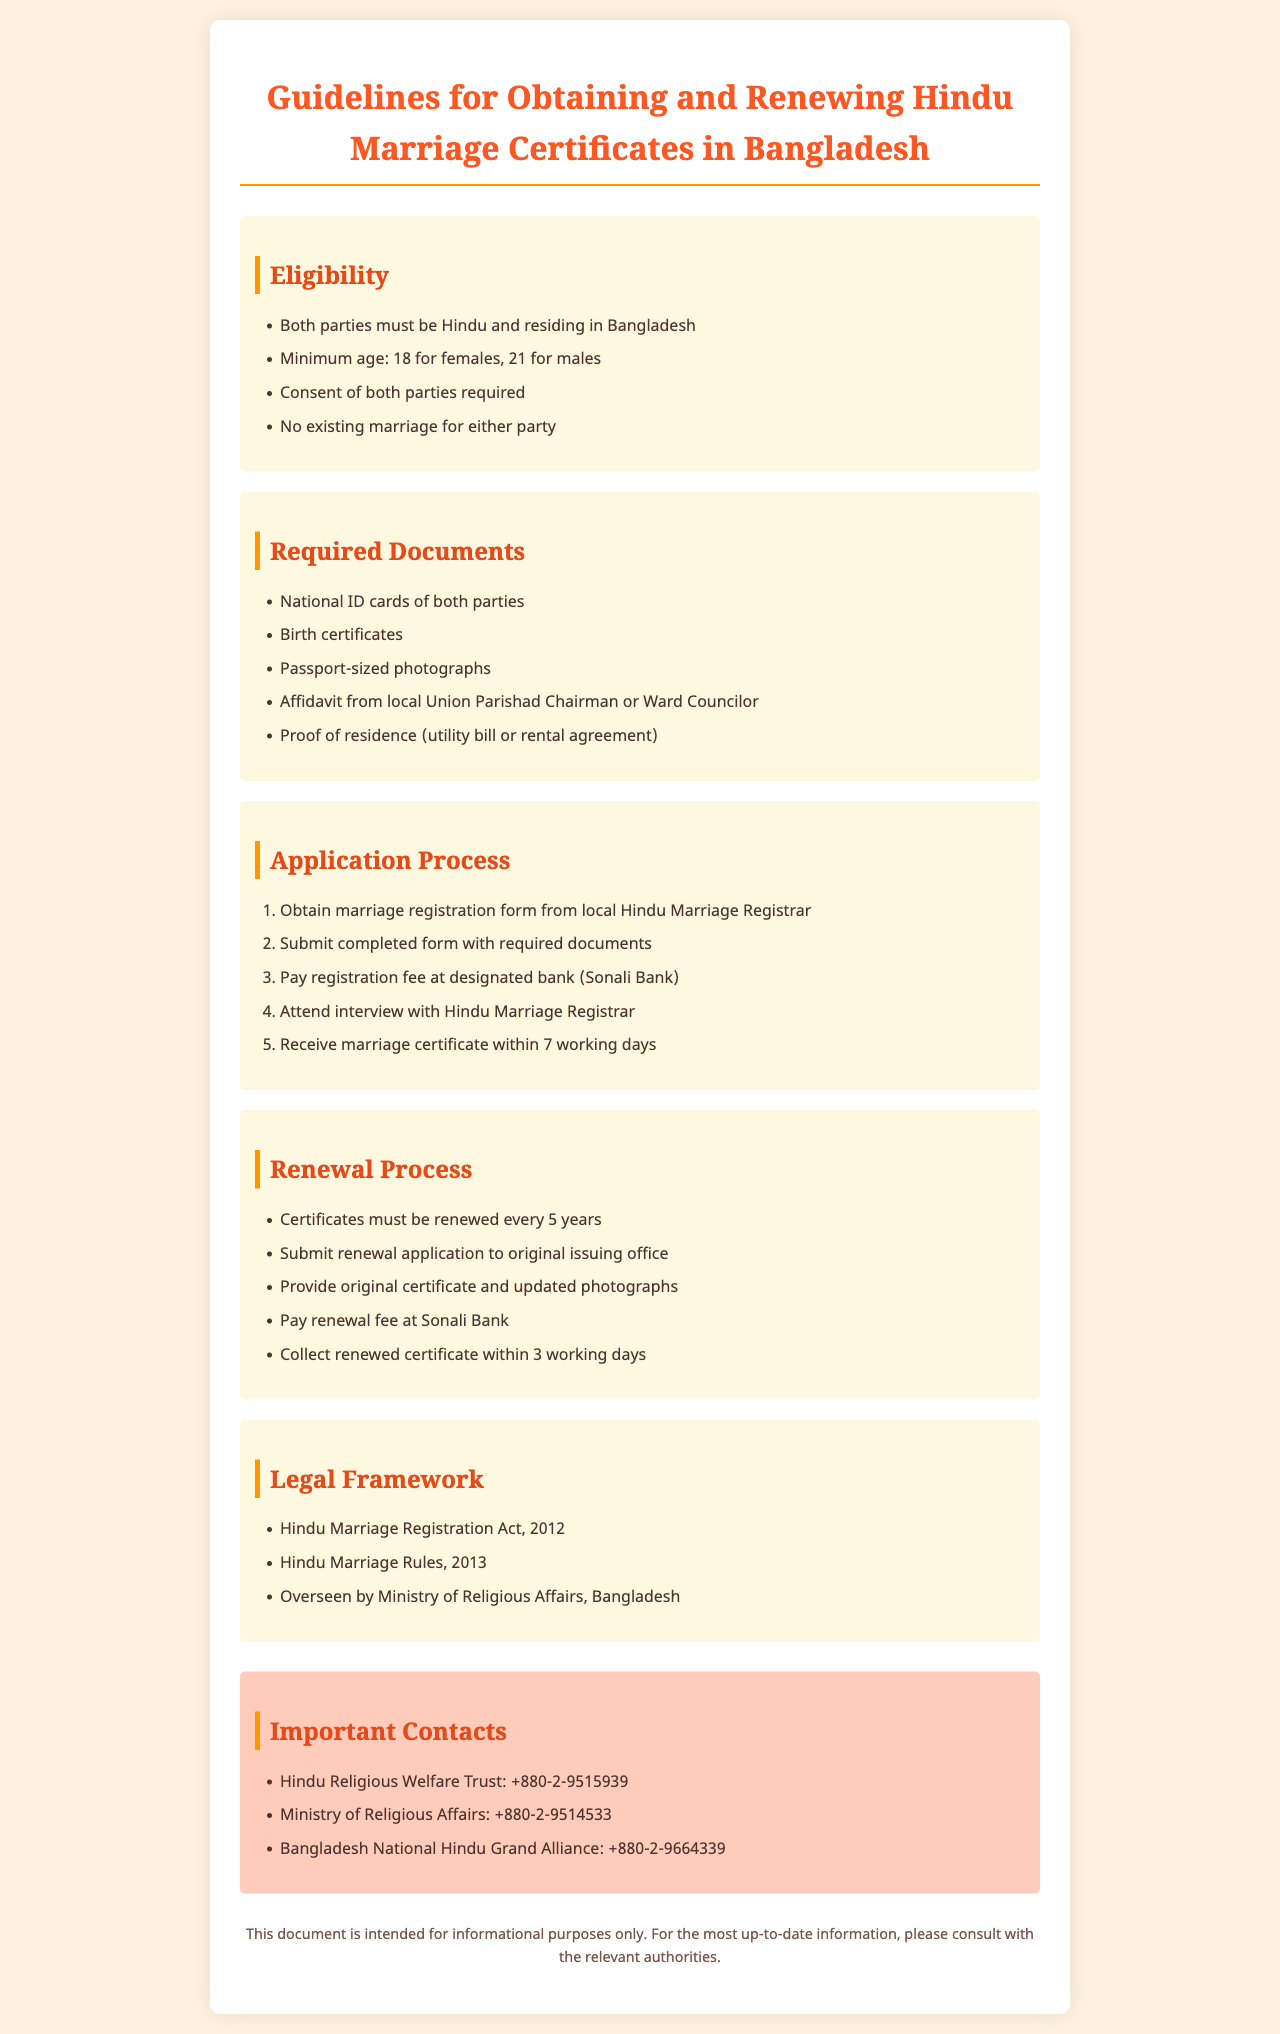What is the minimum age for females to marry? The document states that the minimum age for females is 18.
Answer: 18 What documents are needed for marriage registration? The document provides a list of required documents which includes national ID cards and birth certificates.
Answer: National ID cards, Birth certificates, Passport-sized photographs, Affidavit, Proof of residence How long does it take to receive the marriage certificate? The document mentions that the marriage certificate is received within 7 working days.
Answer: 7 working days What is the renewal period for the marriage certificate? According to the document, certificates must be renewed every 5 years.
Answer: 5 years Who oversees the Hindu Marriage Registration in Bangladesh? The document states that it is overseen by the Ministry of Religious Affairs.
Answer: Ministry of Religious Affairs What is the designated bank for paying the registration fee? The guideline mentions paying the fee at Sonali Bank.
Answer: Sonali Bank What is required during the renewal application process? The document states that providing the original certificate and updated photographs is required for renewal.
Answer: Original certificate, Updated photographs What is the contact number for the Hindu Religious Welfare Trust? The document lists the contact number as +880-2-9515939.
Answer: +880-2-9515939 What must both parties be in order to obtain a marriage certificate? The document specifies that both parties must be Hindu.
Answer: Hindu 